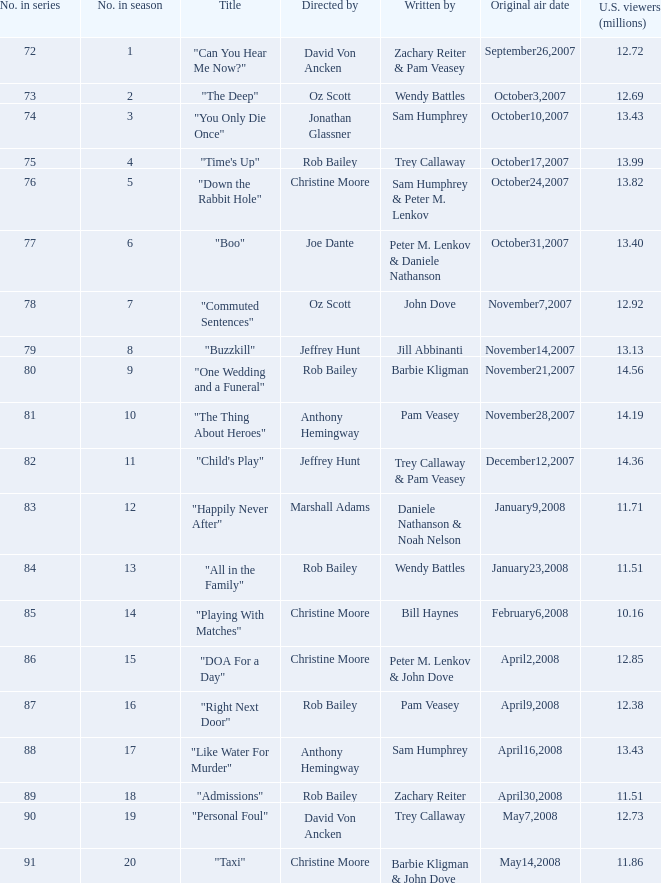How many millions of u.s. spectators viewed the episode "buzzkill"? 1.0. 